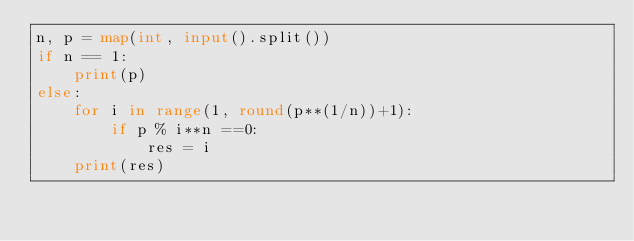Convert code to text. <code><loc_0><loc_0><loc_500><loc_500><_Python_>n, p = map(int, input().split())
if n == 1:
    print(p)
else:
    for i in range(1, round(p**(1/n))+1):
        if p % i**n ==0:
            res = i
    print(res)</code> 